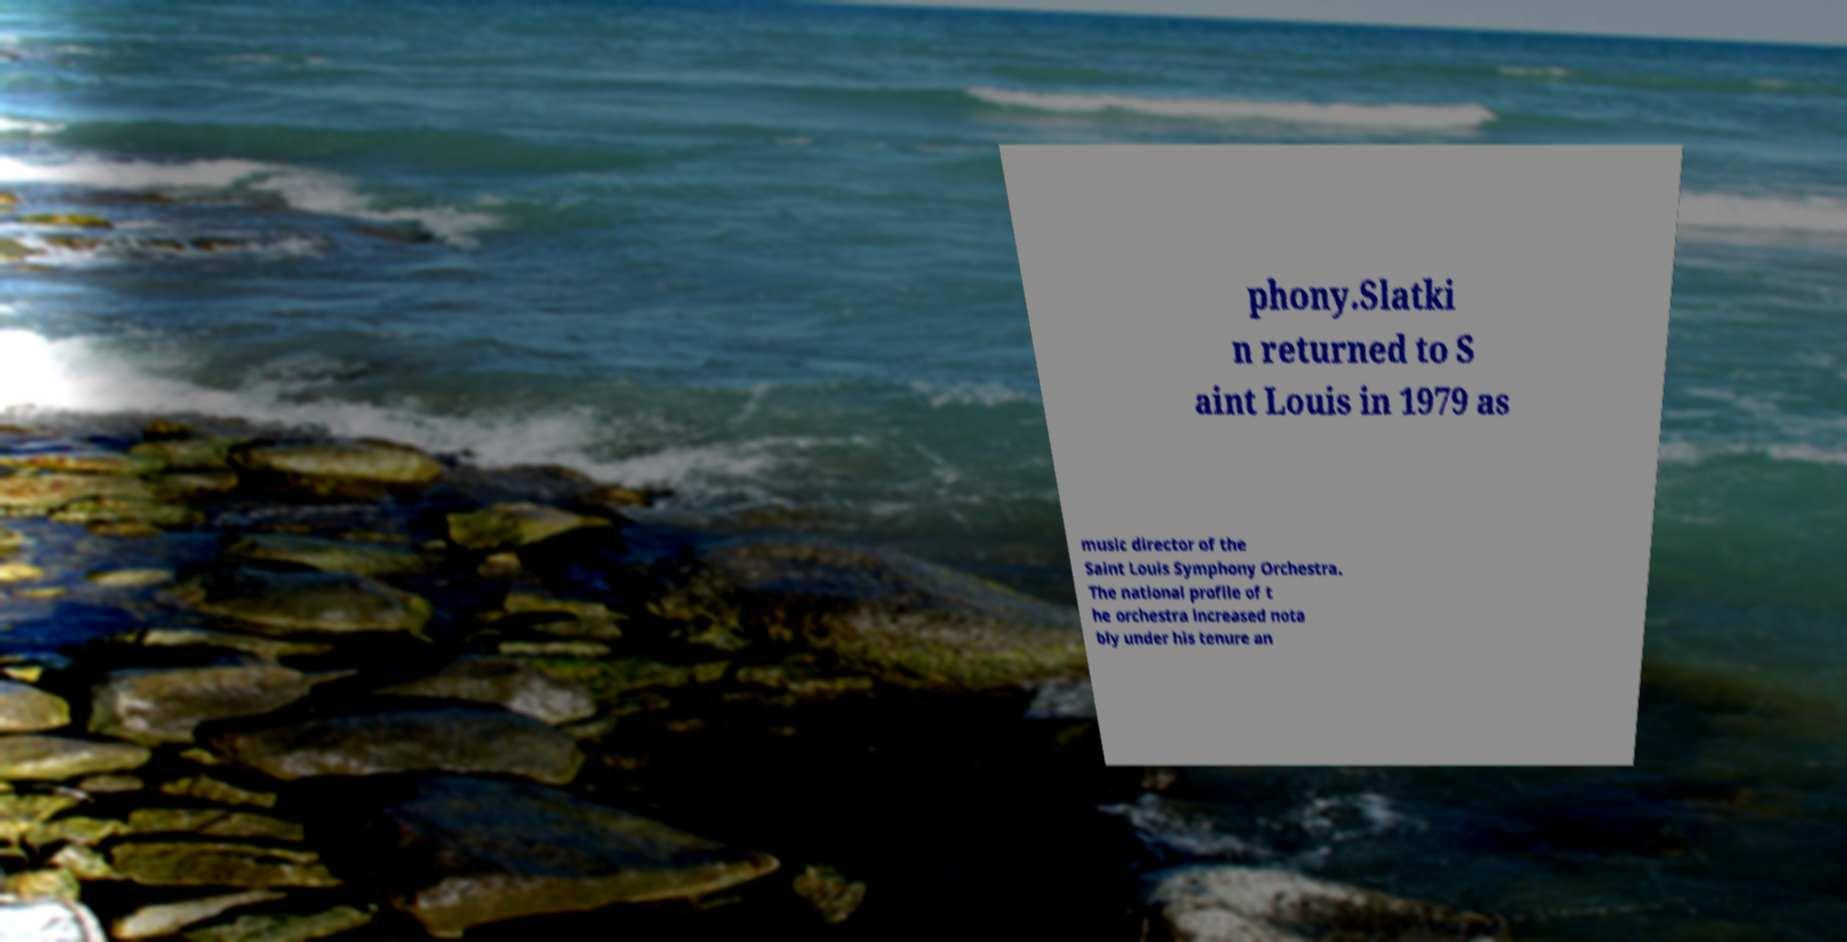Can you accurately transcribe the text from the provided image for me? phony.Slatki n returned to S aint Louis in 1979 as music director of the Saint Louis Symphony Orchestra. The national profile of t he orchestra increased nota bly under his tenure an 